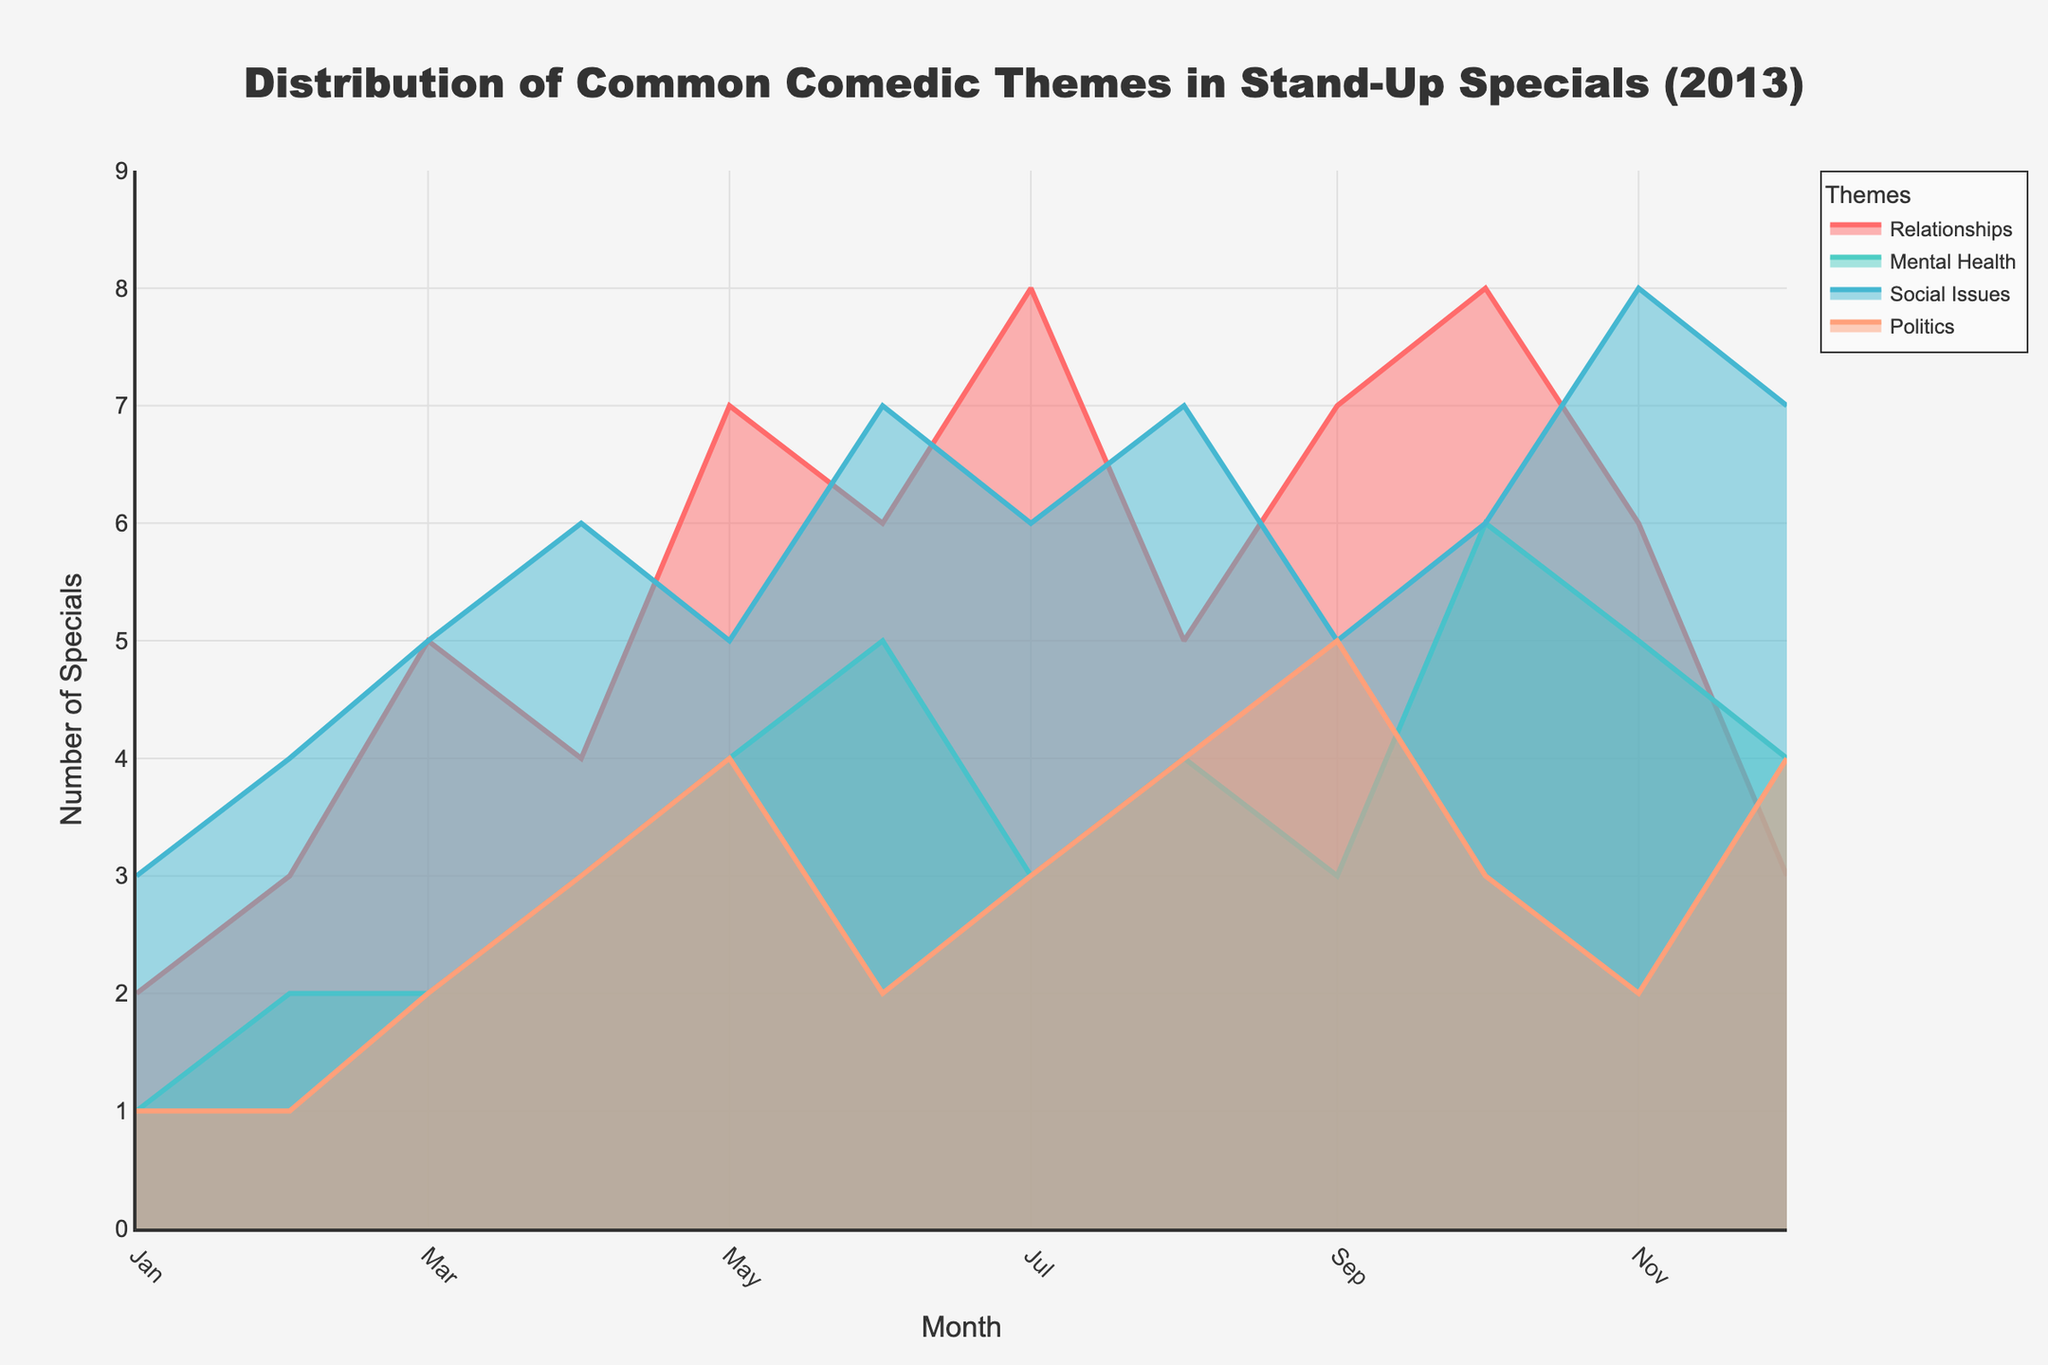What's the title of the plot? At the top of the plot, the title is displayed. It is "Distribution of Common Comedic Themes in Stand-Up Specials (2013)"
Answer: Distribution of Common Comedic Themes in Stand-Up Specials (2013) Which theme has the most specials in December 2013? In December 2013, "Social Issues" has the highest count compared to other themes. It has 7 specials.
Answer: Social Issues During which month did the theme "Relationships" have the highest number of specials? By examining the plot line for "Relationships," we see the peak occurs in July with 8 specials.
Answer: July How many specials on "Mental Health" were released in the entire year? We sum the counts for "Mental Health" from January to December. The sum is 1 + 2 + 2 + 3 + 4 + 5 + 3 + 4 + 3 + 6 + 5 + 4 = 42.
Answer: 42 Which theme showed the greatest increase from January to June? By comparing the initial (January) and mid-year (June) counts for each theme, "Mental Health" shows the largest increase from 1 to 5 (an increase of 4 specials).
Answer: Mental Health Did the count for "Politics" specials increase or decrease from October to November 2013? Observing the plot, the count for "Politics" themes decreased from 3 in October to 2 in November.
Answer: Decrease What is the trend of the "Social Issues" theme throughout the year? The "Social Issues" line shows a general increase from 3 specials in January to peaks around mid-year, followed by slight fluctuations and ending with 7 specials in December.
Answer: General increase with fluctuations Compare the counts of "Relationships" and "Mental Health" themes in May 2013. In May 2013, "Relationships" has 7 specials while "Mental Health" has 4 specials. Thus, "Relationships" has more.
Answer: Relationships: 7, Mental Health: 4 Which theme had the least variation in the number of specials throughout the year? The theme "Politics" exhibits relatively small fluctuations and thus shows the least variation compared to others.
Answer: Politics What generalization can be made about the trend in the number of "Relationships" specials towards the end of the year (October to December)? The line shows that the number of "Relationships" specials decreases from 8 in October to 3 by December, indicating a downward trend.
Answer: Downward trend 